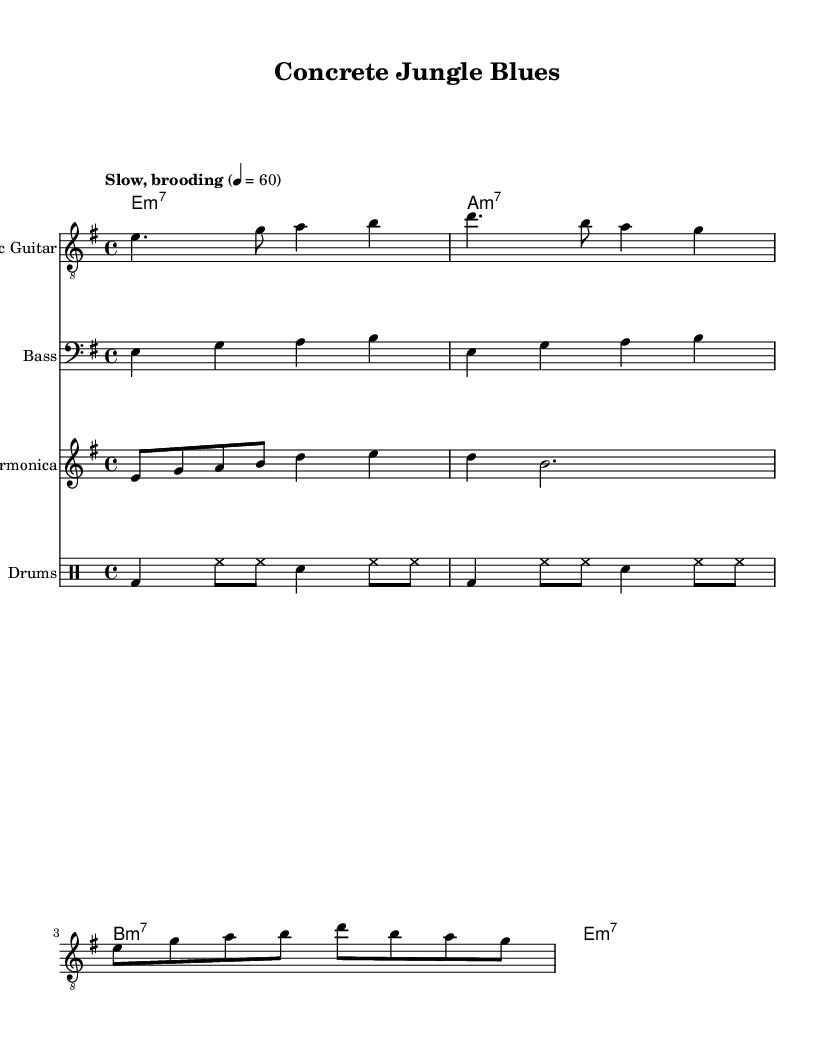What is the key signature of this music? The key signature is E minor, which has one sharp (F#). It is indicated at the beginning of the staff in the key signature area.
Answer: E minor What is the time signature of this piece? The time signature is 4/4, indicated at the beginning of the score. This means there are four beats per measure.
Answer: 4/4 What is the tempo marking for this music? The tempo marking indicates "Slow, brooding," which sets the mood and speed at which the music should be played.
Answer: Slow, brooding How many measures are there in the electric guitar part? By counting the groups of bars in the electric guitar part, we can see there are 4 measures in total. This is determined by the vertical lines indicating the end of each measure.
Answer: 4 Which instruments are included in this score? The score includes Electric Guitar, Bass, Harmonica, and Drums. Each instrument has its own staff notated at the beginning of the score.
Answer: Electric Guitar, Bass, Harmonica, Drums What type of chord is primarily used in this piece? The chords in the score are predominantly minor 7 chords, as indicated by the chord names beneath each measure (e.g., e:m7, a:m7).
Answer: Minor 7 What is the primary theme reflected in the title of this piece? The title "Concrete Jungle Blues" suggests a gritty urban theme related to the darker aspects of city life, which is typical in Electric Blues music.
Answer: Gritty urban theme 